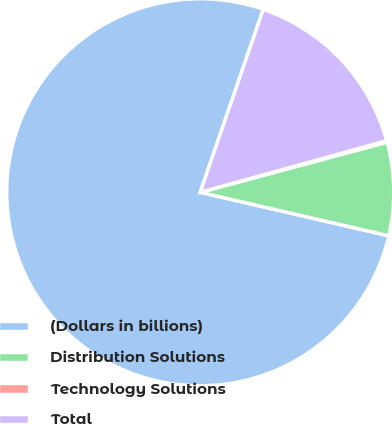Convert chart to OTSL. <chart><loc_0><loc_0><loc_500><loc_500><pie_chart><fcel>(Dollars in billions)<fcel>Distribution Solutions<fcel>Technology Solutions<fcel>Total<nl><fcel>76.67%<fcel>7.78%<fcel>0.12%<fcel>15.43%<nl></chart> 